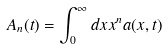Convert formula to latex. <formula><loc_0><loc_0><loc_500><loc_500>A _ { n } ( t ) = \int ^ { \infty } _ { 0 } d x x ^ { n } a ( x , t )</formula> 